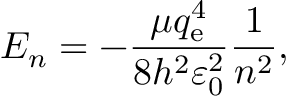Convert formula to latex. <formula><loc_0><loc_0><loc_500><loc_500>E _ { n } = - { \frac { \mu q _ { e } ^ { 4 } } { 8 h ^ { 2 } \varepsilon _ { 0 } ^ { 2 } } } { \frac { 1 } { n ^ { 2 } } } ,</formula> 